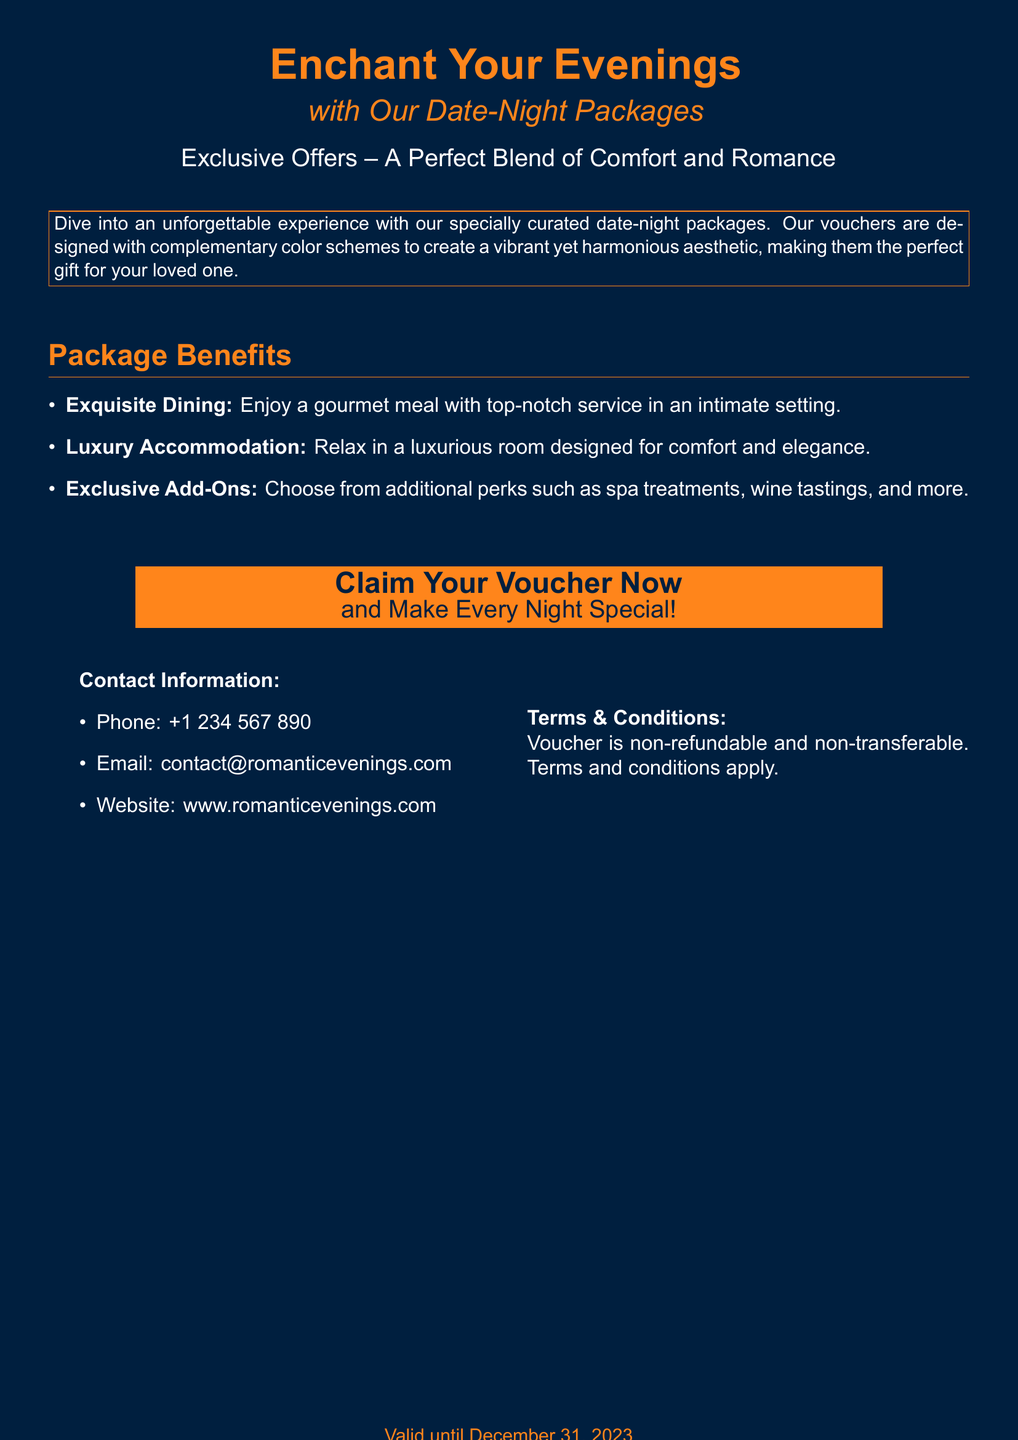What is the title of the voucher? The title is prominently displayed at the top of the voucher, stating the theme of the package.
Answer: Enchant Your Evenings What color scheme is used for the design? The voucher utilizes complementary colors to create a visually appealing layout.
Answer: Complementary color scheme What is the validity date of the voucher? The expiration date is mentioned in the footer as per the document's terms.
Answer: December 31, 2023 What type of dining experience is offered? The package benefits outline the type of dining experience included in the voucher.
Answer: Gourmet meal How many package benefits are listed? The number of bullet points indicates the package benefits included in the voucher.
Answer: Three What is the contact email for the service? The contact email is provided in the contact information section of the document.
Answer: contact@romanticevenings.com What color is used for the main background of the voucher? The background color is set for the entire voucher to create a specific mood.
Answer: Midnight blue What is the purpose of the voucher? The document outlines the primary function and appeal of the voucher to potential consumers.
Answer: Gift for date-night packages 